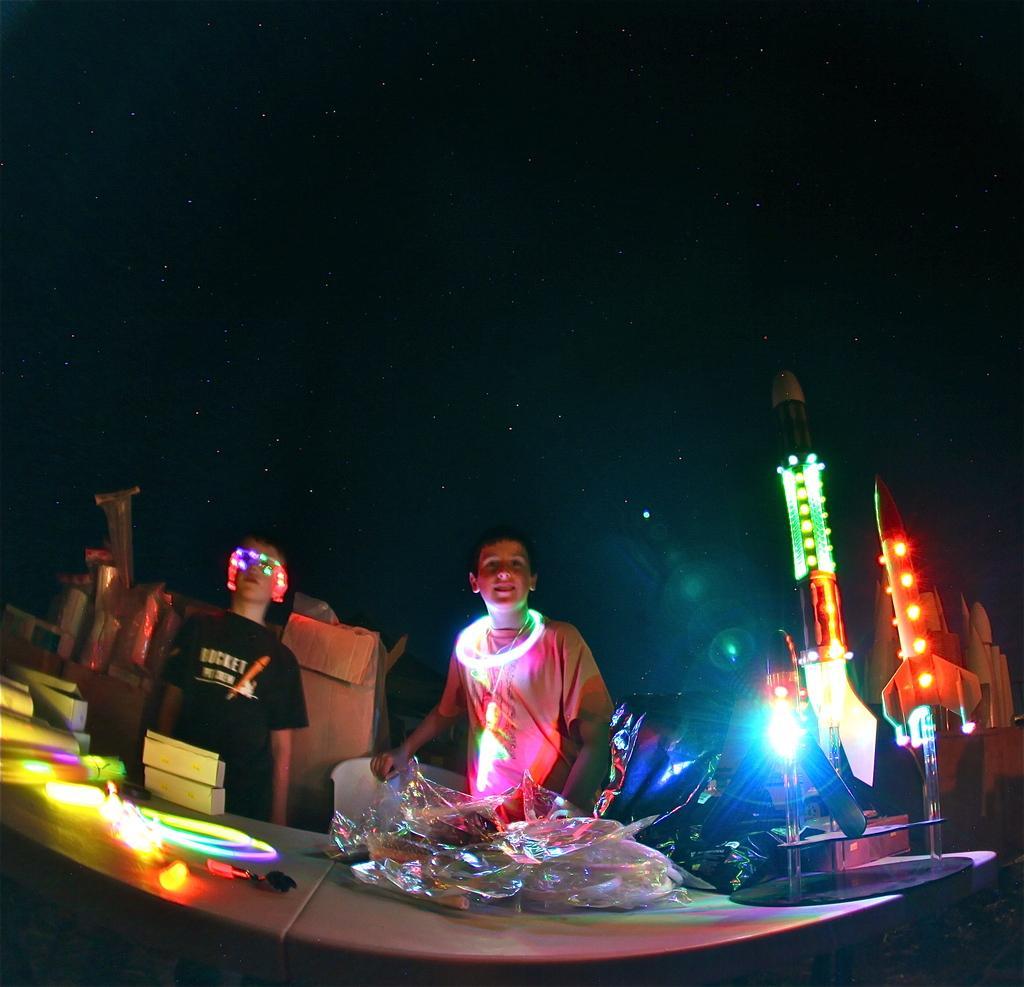Please provide a concise description of this image. In this picture we can see the boy wearing white color t- shirt and standing in the front. Beside there are some light on the rocket. In the front there is a table on which plastic cover and some led light are placed. Behind there is a black color background. 